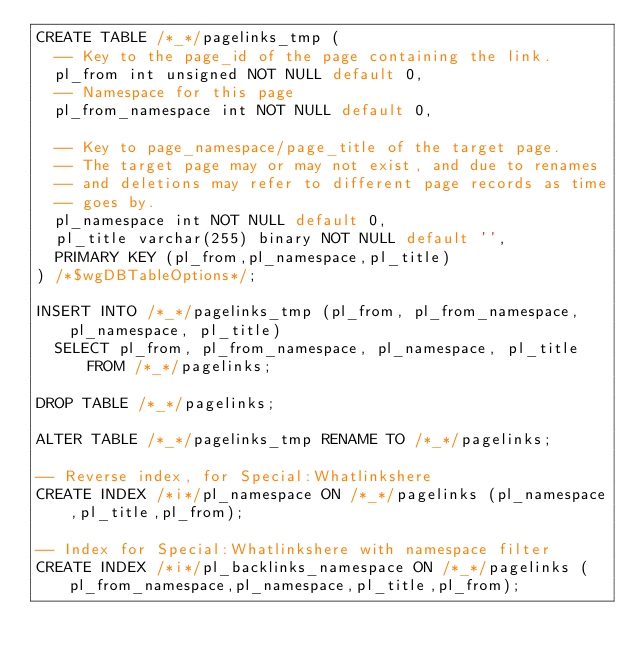Convert code to text. <code><loc_0><loc_0><loc_500><loc_500><_SQL_>CREATE TABLE /*_*/pagelinks_tmp (
  -- Key to the page_id of the page containing the link.
  pl_from int unsigned NOT NULL default 0,
  -- Namespace for this page
  pl_from_namespace int NOT NULL default 0,

  -- Key to page_namespace/page_title of the target page.
  -- The target page may or may not exist, and due to renames
  -- and deletions may refer to different page records as time
  -- goes by.
  pl_namespace int NOT NULL default 0,
  pl_title varchar(255) binary NOT NULL default '',
  PRIMARY KEY (pl_from,pl_namespace,pl_title)
) /*$wgDBTableOptions*/;

INSERT INTO /*_*/pagelinks_tmp (pl_from, pl_from_namespace, pl_namespace, pl_title)
	SELECT pl_from, pl_from_namespace, pl_namespace, pl_title FROM /*_*/pagelinks;

DROP TABLE /*_*/pagelinks;

ALTER TABLE /*_*/pagelinks_tmp RENAME TO /*_*/pagelinks;

-- Reverse index, for Special:Whatlinkshere
CREATE INDEX /*i*/pl_namespace ON /*_*/pagelinks (pl_namespace,pl_title,pl_from);

-- Index for Special:Whatlinkshere with namespace filter
CREATE INDEX /*i*/pl_backlinks_namespace ON /*_*/pagelinks (pl_from_namespace,pl_namespace,pl_title,pl_from);
</code> 